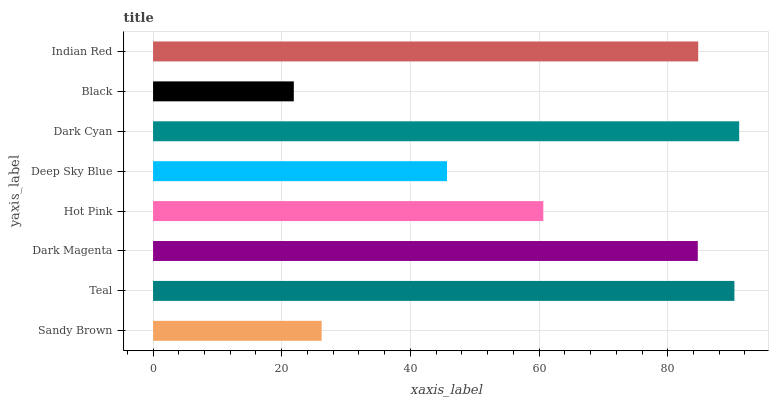Is Black the minimum?
Answer yes or no. Yes. Is Dark Cyan the maximum?
Answer yes or no. Yes. Is Teal the minimum?
Answer yes or no. No. Is Teal the maximum?
Answer yes or no. No. Is Teal greater than Sandy Brown?
Answer yes or no. Yes. Is Sandy Brown less than Teal?
Answer yes or no. Yes. Is Sandy Brown greater than Teal?
Answer yes or no. No. Is Teal less than Sandy Brown?
Answer yes or no. No. Is Dark Magenta the high median?
Answer yes or no. Yes. Is Hot Pink the low median?
Answer yes or no. Yes. Is Hot Pink the high median?
Answer yes or no. No. Is Teal the low median?
Answer yes or no. No. 